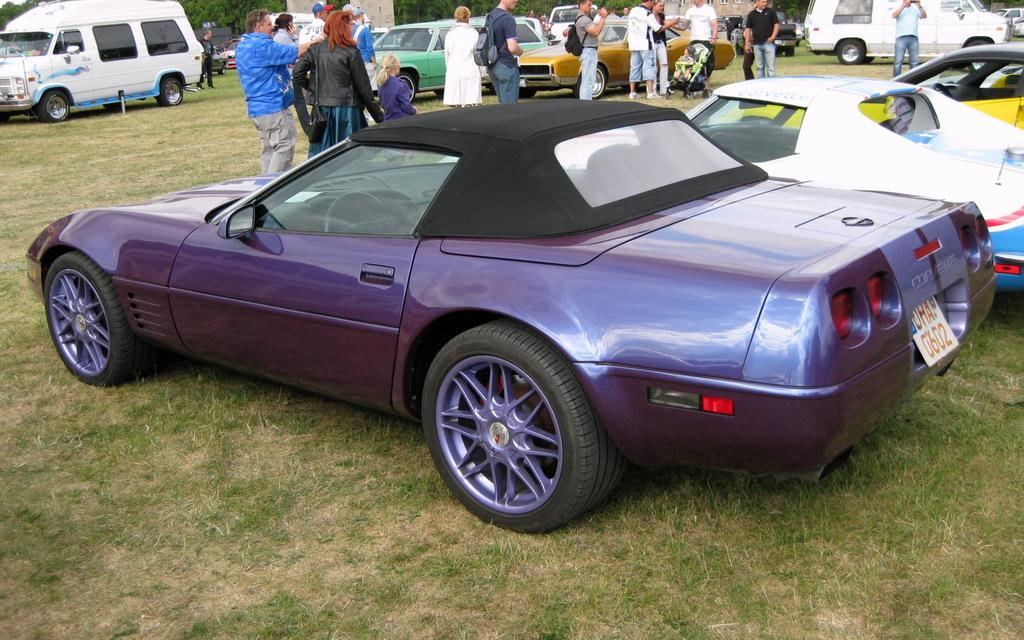What is the main subject of the image? The main subject of the image is a car. Can you describe the car's condition? The car is parked and has a brinjal color. What are the people in the image doing? The people are walking on the grass in the image. Where is the grass located in the image? The grass is at the top of the image. Are there any other vehicles in the image? Yes, there are vehicles parked on the right side of the image. Can you tell me how many hens are present in the image? There are no hens present in the image. Are there any rabbits visible in the image? There are no rabbits visible in the image. 